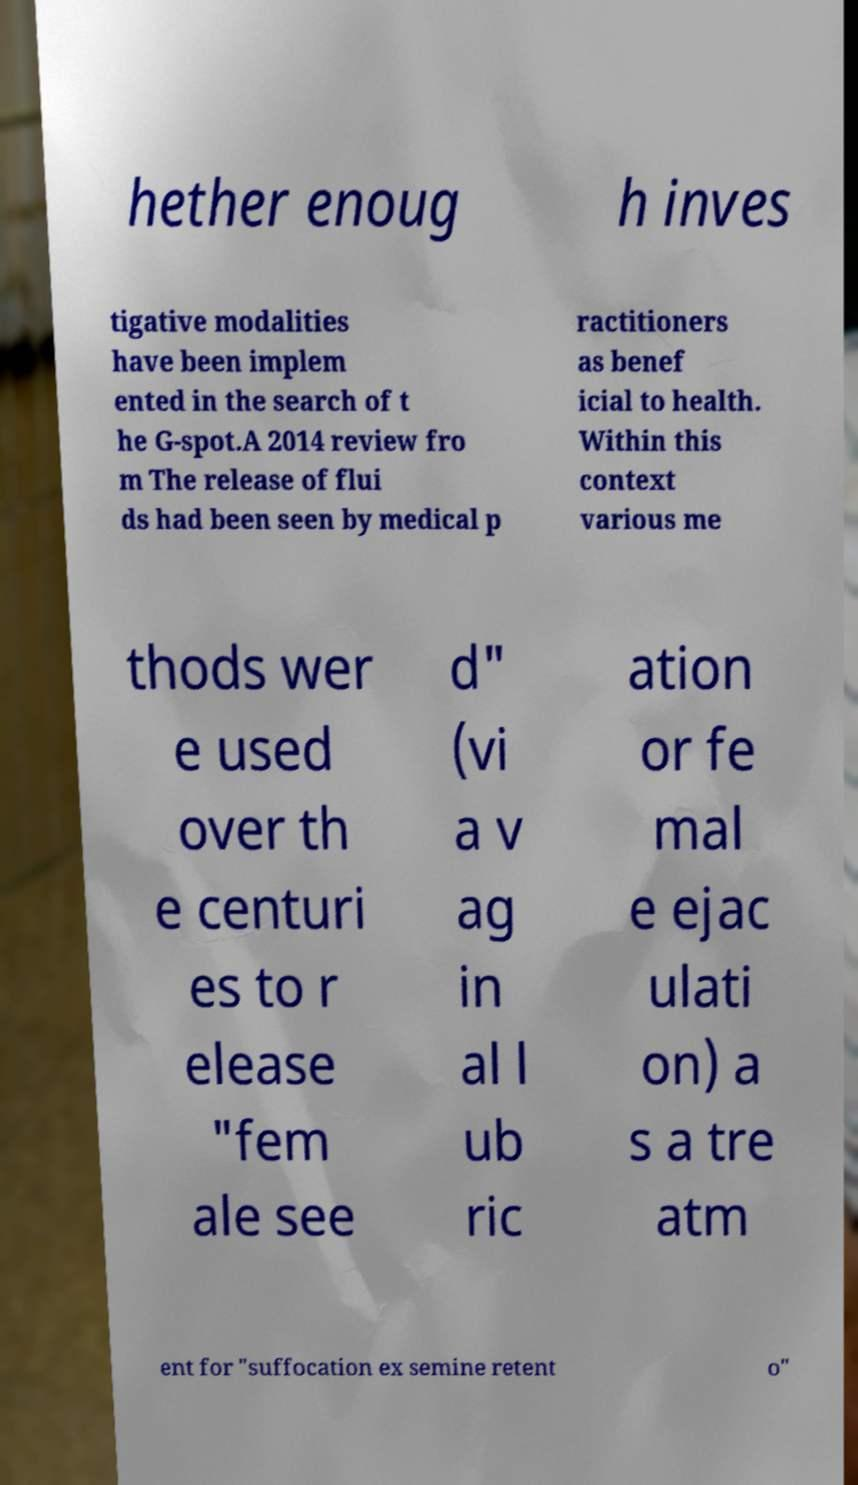Can you read and provide the text displayed in the image?This photo seems to have some interesting text. Can you extract and type it out for me? hether enoug h inves tigative modalities have been implem ented in the search of t he G-spot.A 2014 review fro m The release of flui ds had been seen by medical p ractitioners as benef icial to health. Within this context various me thods wer e used over th e centuri es to r elease "fem ale see d" (vi a v ag in al l ub ric ation or fe mal e ejac ulati on) a s a tre atm ent for "suffocation ex semine retent o" 